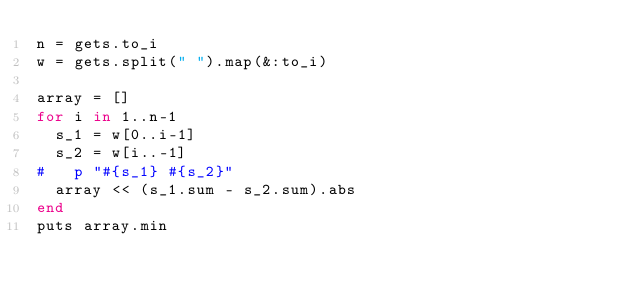<code> <loc_0><loc_0><loc_500><loc_500><_Ruby_>n = gets.to_i
w = gets.split(" ").map(&:to_i)

array = []
for i in 1..n-1
  s_1 = w[0..i-1]
  s_2 = w[i..-1]
#   p "#{s_1} #{s_2}"
  array << (s_1.sum - s_2.sum).abs
end
puts array.min</code> 